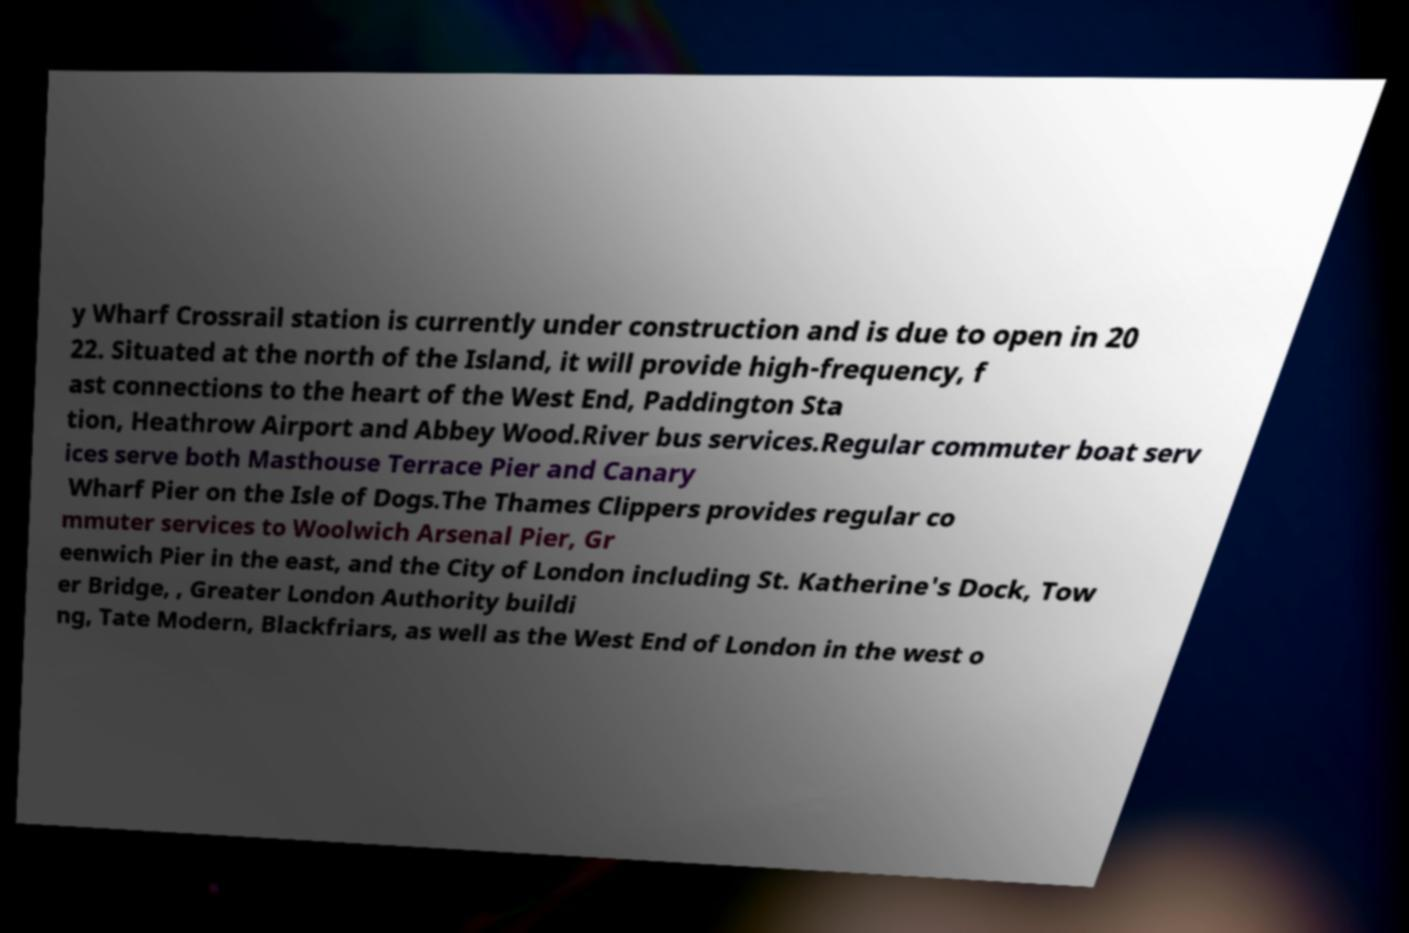Could you assist in decoding the text presented in this image and type it out clearly? y Wharf Crossrail station is currently under construction and is due to open in 20 22. Situated at the north of the Island, it will provide high-frequency, f ast connections to the heart of the West End, Paddington Sta tion, Heathrow Airport and Abbey Wood.River bus services.Regular commuter boat serv ices serve both Masthouse Terrace Pier and Canary Wharf Pier on the Isle of Dogs.The Thames Clippers provides regular co mmuter services to Woolwich Arsenal Pier, Gr eenwich Pier in the east, and the City of London including St. Katherine's Dock, Tow er Bridge, , Greater London Authority buildi ng, Tate Modern, Blackfriars, as well as the West End of London in the west o 